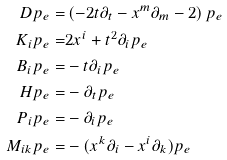<formula> <loc_0><loc_0><loc_500><loc_500>D p _ { e } = & \left ( - 2 t \partial _ { t } - x ^ { m } \partial _ { m } - 2 \right ) p _ { e } \\ K _ { i } p _ { e } = & 2 x ^ { i } + t ^ { 2 } \partial _ { i } p _ { e } \\ B _ { i } p _ { e } = & - t \partial _ { i } p _ { e } \\ H p _ { e } = & - \partial _ { t } p _ { e } \\ P _ { i } p _ { e } = & - \partial _ { i } p _ { e } \\ M _ { i k } p _ { e } = & - ( x ^ { k } \partial _ { i } - x ^ { i } \partial _ { k } ) p _ { e } \\</formula> 